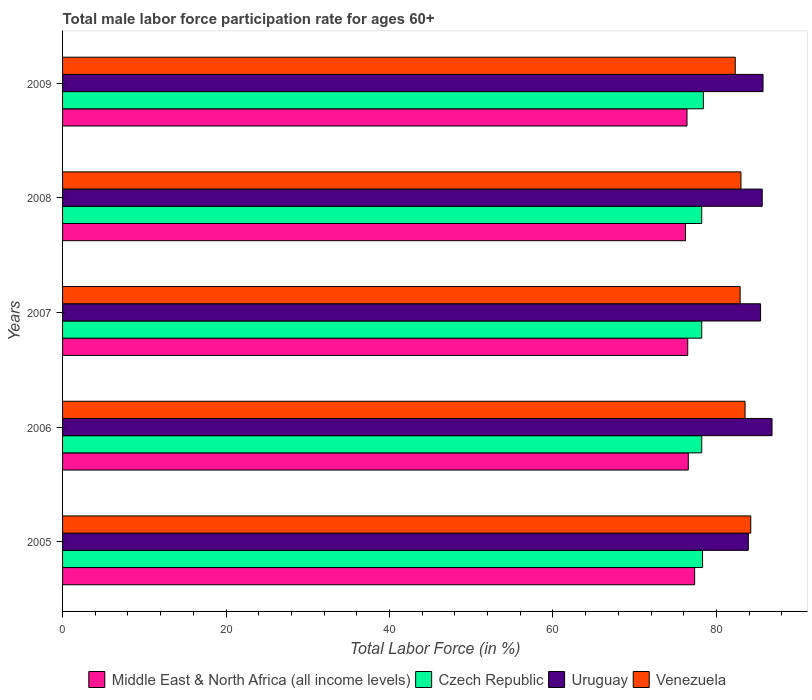How many different coloured bars are there?
Your answer should be compact. 4. How many bars are there on the 5th tick from the top?
Make the answer very short. 4. How many bars are there on the 2nd tick from the bottom?
Offer a very short reply. 4. What is the male labor force participation rate in Czech Republic in 2009?
Provide a short and direct response. 78.4. Across all years, what is the maximum male labor force participation rate in Venezuela?
Your answer should be very brief. 84.2. Across all years, what is the minimum male labor force participation rate in Middle East & North Africa (all income levels)?
Ensure brevity in your answer.  76.21. What is the total male labor force participation rate in Uruguay in the graph?
Give a very brief answer. 427.4. What is the difference between the male labor force participation rate in Uruguay in 2008 and that in 2009?
Offer a very short reply. -0.1. What is the difference between the male labor force participation rate in Venezuela in 2006 and the male labor force participation rate in Middle East & North Africa (all income levels) in 2009?
Make the answer very short. 7.1. What is the average male labor force participation rate in Middle East & North Africa (all income levels) per year?
Your answer should be compact. 76.6. In the year 2008, what is the difference between the male labor force participation rate in Uruguay and male labor force participation rate in Venezuela?
Your response must be concise. 2.6. In how many years, is the male labor force participation rate in Venezuela greater than 52 %?
Offer a very short reply. 5. What is the ratio of the male labor force participation rate in Uruguay in 2006 to that in 2008?
Your answer should be compact. 1.01. Is the male labor force participation rate in Uruguay in 2005 less than that in 2007?
Provide a succinct answer. Yes. Is the difference between the male labor force participation rate in Uruguay in 2006 and 2007 greater than the difference between the male labor force participation rate in Venezuela in 2006 and 2007?
Give a very brief answer. Yes. What is the difference between the highest and the second highest male labor force participation rate in Middle East & North Africa (all income levels)?
Offer a very short reply. 0.78. What is the difference between the highest and the lowest male labor force participation rate in Middle East & North Africa (all income levels)?
Keep it short and to the point. 1.12. In how many years, is the male labor force participation rate in Venezuela greater than the average male labor force participation rate in Venezuela taken over all years?
Keep it short and to the point. 2. What does the 4th bar from the top in 2006 represents?
Your answer should be compact. Middle East & North Africa (all income levels). What does the 2nd bar from the bottom in 2007 represents?
Give a very brief answer. Czech Republic. Is it the case that in every year, the sum of the male labor force participation rate in Uruguay and male labor force participation rate in Czech Republic is greater than the male labor force participation rate in Middle East & North Africa (all income levels)?
Provide a succinct answer. Yes. Are all the bars in the graph horizontal?
Your answer should be very brief. Yes. What is the difference between two consecutive major ticks on the X-axis?
Offer a terse response. 20. Does the graph contain grids?
Make the answer very short. No. How are the legend labels stacked?
Provide a succinct answer. Horizontal. What is the title of the graph?
Your answer should be very brief. Total male labor force participation rate for ages 60+. Does "Mongolia" appear as one of the legend labels in the graph?
Your answer should be very brief. No. What is the label or title of the X-axis?
Provide a succinct answer. Total Labor Force (in %). What is the Total Labor Force (in %) in Middle East & North Africa (all income levels) in 2005?
Keep it short and to the point. 77.33. What is the Total Labor Force (in %) in Czech Republic in 2005?
Provide a succinct answer. 78.3. What is the Total Labor Force (in %) in Uruguay in 2005?
Offer a terse response. 83.9. What is the Total Labor Force (in %) of Venezuela in 2005?
Give a very brief answer. 84.2. What is the Total Labor Force (in %) in Middle East & North Africa (all income levels) in 2006?
Your answer should be very brief. 76.56. What is the Total Labor Force (in %) of Czech Republic in 2006?
Offer a very short reply. 78.2. What is the Total Labor Force (in %) of Uruguay in 2006?
Make the answer very short. 86.8. What is the Total Labor Force (in %) of Venezuela in 2006?
Give a very brief answer. 83.5. What is the Total Labor Force (in %) of Middle East & North Africa (all income levels) in 2007?
Provide a succinct answer. 76.49. What is the Total Labor Force (in %) of Czech Republic in 2007?
Your response must be concise. 78.2. What is the Total Labor Force (in %) in Uruguay in 2007?
Offer a terse response. 85.4. What is the Total Labor Force (in %) in Venezuela in 2007?
Provide a succinct answer. 82.9. What is the Total Labor Force (in %) of Middle East & North Africa (all income levels) in 2008?
Offer a terse response. 76.21. What is the Total Labor Force (in %) of Czech Republic in 2008?
Offer a terse response. 78.2. What is the Total Labor Force (in %) of Uruguay in 2008?
Provide a short and direct response. 85.6. What is the Total Labor Force (in %) in Venezuela in 2008?
Give a very brief answer. 83. What is the Total Labor Force (in %) of Middle East & North Africa (all income levels) in 2009?
Ensure brevity in your answer.  76.4. What is the Total Labor Force (in %) in Czech Republic in 2009?
Ensure brevity in your answer.  78.4. What is the Total Labor Force (in %) of Uruguay in 2009?
Your answer should be compact. 85.7. What is the Total Labor Force (in %) in Venezuela in 2009?
Offer a very short reply. 82.3. Across all years, what is the maximum Total Labor Force (in %) in Middle East & North Africa (all income levels)?
Your response must be concise. 77.33. Across all years, what is the maximum Total Labor Force (in %) of Czech Republic?
Ensure brevity in your answer.  78.4. Across all years, what is the maximum Total Labor Force (in %) in Uruguay?
Keep it short and to the point. 86.8. Across all years, what is the maximum Total Labor Force (in %) of Venezuela?
Ensure brevity in your answer.  84.2. Across all years, what is the minimum Total Labor Force (in %) in Middle East & North Africa (all income levels)?
Provide a short and direct response. 76.21. Across all years, what is the minimum Total Labor Force (in %) of Czech Republic?
Give a very brief answer. 78.2. Across all years, what is the minimum Total Labor Force (in %) in Uruguay?
Give a very brief answer. 83.9. Across all years, what is the minimum Total Labor Force (in %) in Venezuela?
Offer a terse response. 82.3. What is the total Total Labor Force (in %) of Middle East & North Africa (all income levels) in the graph?
Your answer should be compact. 382.99. What is the total Total Labor Force (in %) of Czech Republic in the graph?
Keep it short and to the point. 391.3. What is the total Total Labor Force (in %) in Uruguay in the graph?
Make the answer very short. 427.4. What is the total Total Labor Force (in %) in Venezuela in the graph?
Keep it short and to the point. 415.9. What is the difference between the Total Labor Force (in %) in Middle East & North Africa (all income levels) in 2005 and that in 2006?
Your answer should be very brief. 0.78. What is the difference between the Total Labor Force (in %) of Czech Republic in 2005 and that in 2006?
Provide a short and direct response. 0.1. What is the difference between the Total Labor Force (in %) of Venezuela in 2005 and that in 2006?
Your answer should be compact. 0.7. What is the difference between the Total Labor Force (in %) in Middle East & North Africa (all income levels) in 2005 and that in 2007?
Your answer should be very brief. 0.85. What is the difference between the Total Labor Force (in %) in Czech Republic in 2005 and that in 2007?
Keep it short and to the point. 0.1. What is the difference between the Total Labor Force (in %) in Uruguay in 2005 and that in 2007?
Your response must be concise. -1.5. What is the difference between the Total Labor Force (in %) of Venezuela in 2005 and that in 2007?
Your answer should be very brief. 1.3. What is the difference between the Total Labor Force (in %) of Middle East & North Africa (all income levels) in 2005 and that in 2008?
Offer a terse response. 1.12. What is the difference between the Total Labor Force (in %) in Venezuela in 2005 and that in 2008?
Offer a very short reply. 1.2. What is the difference between the Total Labor Force (in %) of Middle East & North Africa (all income levels) in 2005 and that in 2009?
Offer a very short reply. 0.93. What is the difference between the Total Labor Force (in %) of Middle East & North Africa (all income levels) in 2006 and that in 2007?
Offer a terse response. 0.07. What is the difference between the Total Labor Force (in %) in Venezuela in 2006 and that in 2007?
Offer a very short reply. 0.6. What is the difference between the Total Labor Force (in %) of Middle East & North Africa (all income levels) in 2006 and that in 2008?
Offer a very short reply. 0.34. What is the difference between the Total Labor Force (in %) of Czech Republic in 2006 and that in 2008?
Your response must be concise. 0. What is the difference between the Total Labor Force (in %) of Uruguay in 2006 and that in 2008?
Offer a very short reply. 1.2. What is the difference between the Total Labor Force (in %) of Venezuela in 2006 and that in 2008?
Make the answer very short. 0.5. What is the difference between the Total Labor Force (in %) in Middle East & North Africa (all income levels) in 2006 and that in 2009?
Ensure brevity in your answer.  0.16. What is the difference between the Total Labor Force (in %) in Venezuela in 2006 and that in 2009?
Provide a succinct answer. 1.2. What is the difference between the Total Labor Force (in %) of Middle East & North Africa (all income levels) in 2007 and that in 2008?
Your answer should be compact. 0.27. What is the difference between the Total Labor Force (in %) of Czech Republic in 2007 and that in 2008?
Offer a terse response. 0. What is the difference between the Total Labor Force (in %) of Uruguay in 2007 and that in 2008?
Provide a short and direct response. -0.2. What is the difference between the Total Labor Force (in %) of Middle East & North Africa (all income levels) in 2007 and that in 2009?
Give a very brief answer. 0.09. What is the difference between the Total Labor Force (in %) of Uruguay in 2007 and that in 2009?
Offer a very short reply. -0.3. What is the difference between the Total Labor Force (in %) of Venezuela in 2007 and that in 2009?
Give a very brief answer. 0.6. What is the difference between the Total Labor Force (in %) of Middle East & North Africa (all income levels) in 2008 and that in 2009?
Provide a short and direct response. -0.18. What is the difference between the Total Labor Force (in %) of Czech Republic in 2008 and that in 2009?
Keep it short and to the point. -0.2. What is the difference between the Total Labor Force (in %) of Uruguay in 2008 and that in 2009?
Offer a terse response. -0.1. What is the difference between the Total Labor Force (in %) in Venezuela in 2008 and that in 2009?
Make the answer very short. 0.7. What is the difference between the Total Labor Force (in %) in Middle East & North Africa (all income levels) in 2005 and the Total Labor Force (in %) in Czech Republic in 2006?
Keep it short and to the point. -0.87. What is the difference between the Total Labor Force (in %) of Middle East & North Africa (all income levels) in 2005 and the Total Labor Force (in %) of Uruguay in 2006?
Ensure brevity in your answer.  -9.47. What is the difference between the Total Labor Force (in %) in Middle East & North Africa (all income levels) in 2005 and the Total Labor Force (in %) in Venezuela in 2006?
Provide a succinct answer. -6.17. What is the difference between the Total Labor Force (in %) in Czech Republic in 2005 and the Total Labor Force (in %) in Venezuela in 2006?
Keep it short and to the point. -5.2. What is the difference between the Total Labor Force (in %) in Middle East & North Africa (all income levels) in 2005 and the Total Labor Force (in %) in Czech Republic in 2007?
Your answer should be very brief. -0.87. What is the difference between the Total Labor Force (in %) of Middle East & North Africa (all income levels) in 2005 and the Total Labor Force (in %) of Uruguay in 2007?
Provide a succinct answer. -8.07. What is the difference between the Total Labor Force (in %) in Middle East & North Africa (all income levels) in 2005 and the Total Labor Force (in %) in Venezuela in 2007?
Your response must be concise. -5.57. What is the difference between the Total Labor Force (in %) in Czech Republic in 2005 and the Total Labor Force (in %) in Uruguay in 2007?
Make the answer very short. -7.1. What is the difference between the Total Labor Force (in %) in Czech Republic in 2005 and the Total Labor Force (in %) in Venezuela in 2007?
Keep it short and to the point. -4.6. What is the difference between the Total Labor Force (in %) of Uruguay in 2005 and the Total Labor Force (in %) of Venezuela in 2007?
Provide a succinct answer. 1. What is the difference between the Total Labor Force (in %) in Middle East & North Africa (all income levels) in 2005 and the Total Labor Force (in %) in Czech Republic in 2008?
Offer a terse response. -0.87. What is the difference between the Total Labor Force (in %) of Middle East & North Africa (all income levels) in 2005 and the Total Labor Force (in %) of Uruguay in 2008?
Offer a terse response. -8.27. What is the difference between the Total Labor Force (in %) in Middle East & North Africa (all income levels) in 2005 and the Total Labor Force (in %) in Venezuela in 2008?
Your answer should be compact. -5.67. What is the difference between the Total Labor Force (in %) in Czech Republic in 2005 and the Total Labor Force (in %) in Uruguay in 2008?
Offer a terse response. -7.3. What is the difference between the Total Labor Force (in %) of Czech Republic in 2005 and the Total Labor Force (in %) of Venezuela in 2008?
Ensure brevity in your answer.  -4.7. What is the difference between the Total Labor Force (in %) in Middle East & North Africa (all income levels) in 2005 and the Total Labor Force (in %) in Czech Republic in 2009?
Offer a terse response. -1.07. What is the difference between the Total Labor Force (in %) of Middle East & North Africa (all income levels) in 2005 and the Total Labor Force (in %) of Uruguay in 2009?
Your answer should be very brief. -8.37. What is the difference between the Total Labor Force (in %) of Middle East & North Africa (all income levels) in 2005 and the Total Labor Force (in %) of Venezuela in 2009?
Provide a short and direct response. -4.97. What is the difference between the Total Labor Force (in %) in Czech Republic in 2005 and the Total Labor Force (in %) in Venezuela in 2009?
Your answer should be compact. -4. What is the difference between the Total Labor Force (in %) of Uruguay in 2005 and the Total Labor Force (in %) of Venezuela in 2009?
Offer a very short reply. 1.6. What is the difference between the Total Labor Force (in %) in Middle East & North Africa (all income levels) in 2006 and the Total Labor Force (in %) in Czech Republic in 2007?
Keep it short and to the point. -1.64. What is the difference between the Total Labor Force (in %) in Middle East & North Africa (all income levels) in 2006 and the Total Labor Force (in %) in Uruguay in 2007?
Keep it short and to the point. -8.84. What is the difference between the Total Labor Force (in %) in Middle East & North Africa (all income levels) in 2006 and the Total Labor Force (in %) in Venezuela in 2007?
Ensure brevity in your answer.  -6.34. What is the difference between the Total Labor Force (in %) of Czech Republic in 2006 and the Total Labor Force (in %) of Uruguay in 2007?
Your answer should be very brief. -7.2. What is the difference between the Total Labor Force (in %) of Uruguay in 2006 and the Total Labor Force (in %) of Venezuela in 2007?
Give a very brief answer. 3.9. What is the difference between the Total Labor Force (in %) in Middle East & North Africa (all income levels) in 2006 and the Total Labor Force (in %) in Czech Republic in 2008?
Provide a succinct answer. -1.64. What is the difference between the Total Labor Force (in %) of Middle East & North Africa (all income levels) in 2006 and the Total Labor Force (in %) of Uruguay in 2008?
Provide a short and direct response. -9.04. What is the difference between the Total Labor Force (in %) of Middle East & North Africa (all income levels) in 2006 and the Total Labor Force (in %) of Venezuela in 2008?
Your answer should be very brief. -6.44. What is the difference between the Total Labor Force (in %) in Czech Republic in 2006 and the Total Labor Force (in %) in Uruguay in 2008?
Your response must be concise. -7.4. What is the difference between the Total Labor Force (in %) of Czech Republic in 2006 and the Total Labor Force (in %) of Venezuela in 2008?
Offer a very short reply. -4.8. What is the difference between the Total Labor Force (in %) of Middle East & North Africa (all income levels) in 2006 and the Total Labor Force (in %) of Czech Republic in 2009?
Your response must be concise. -1.84. What is the difference between the Total Labor Force (in %) of Middle East & North Africa (all income levels) in 2006 and the Total Labor Force (in %) of Uruguay in 2009?
Offer a very short reply. -9.14. What is the difference between the Total Labor Force (in %) of Middle East & North Africa (all income levels) in 2006 and the Total Labor Force (in %) of Venezuela in 2009?
Your response must be concise. -5.74. What is the difference between the Total Labor Force (in %) in Uruguay in 2006 and the Total Labor Force (in %) in Venezuela in 2009?
Your answer should be compact. 4.5. What is the difference between the Total Labor Force (in %) in Middle East & North Africa (all income levels) in 2007 and the Total Labor Force (in %) in Czech Republic in 2008?
Ensure brevity in your answer.  -1.71. What is the difference between the Total Labor Force (in %) in Middle East & North Africa (all income levels) in 2007 and the Total Labor Force (in %) in Uruguay in 2008?
Your answer should be compact. -9.11. What is the difference between the Total Labor Force (in %) in Middle East & North Africa (all income levels) in 2007 and the Total Labor Force (in %) in Venezuela in 2008?
Provide a succinct answer. -6.51. What is the difference between the Total Labor Force (in %) of Czech Republic in 2007 and the Total Labor Force (in %) of Venezuela in 2008?
Provide a short and direct response. -4.8. What is the difference between the Total Labor Force (in %) in Middle East & North Africa (all income levels) in 2007 and the Total Labor Force (in %) in Czech Republic in 2009?
Give a very brief answer. -1.91. What is the difference between the Total Labor Force (in %) in Middle East & North Africa (all income levels) in 2007 and the Total Labor Force (in %) in Uruguay in 2009?
Your answer should be very brief. -9.21. What is the difference between the Total Labor Force (in %) of Middle East & North Africa (all income levels) in 2007 and the Total Labor Force (in %) of Venezuela in 2009?
Ensure brevity in your answer.  -5.81. What is the difference between the Total Labor Force (in %) of Middle East & North Africa (all income levels) in 2008 and the Total Labor Force (in %) of Czech Republic in 2009?
Keep it short and to the point. -2.19. What is the difference between the Total Labor Force (in %) of Middle East & North Africa (all income levels) in 2008 and the Total Labor Force (in %) of Uruguay in 2009?
Keep it short and to the point. -9.49. What is the difference between the Total Labor Force (in %) of Middle East & North Africa (all income levels) in 2008 and the Total Labor Force (in %) of Venezuela in 2009?
Provide a short and direct response. -6.09. What is the difference between the Total Labor Force (in %) in Czech Republic in 2008 and the Total Labor Force (in %) in Uruguay in 2009?
Keep it short and to the point. -7.5. What is the average Total Labor Force (in %) in Middle East & North Africa (all income levels) per year?
Your answer should be compact. 76.6. What is the average Total Labor Force (in %) in Czech Republic per year?
Make the answer very short. 78.26. What is the average Total Labor Force (in %) of Uruguay per year?
Offer a very short reply. 85.48. What is the average Total Labor Force (in %) in Venezuela per year?
Make the answer very short. 83.18. In the year 2005, what is the difference between the Total Labor Force (in %) in Middle East & North Africa (all income levels) and Total Labor Force (in %) in Czech Republic?
Your answer should be very brief. -0.97. In the year 2005, what is the difference between the Total Labor Force (in %) in Middle East & North Africa (all income levels) and Total Labor Force (in %) in Uruguay?
Offer a terse response. -6.57. In the year 2005, what is the difference between the Total Labor Force (in %) in Middle East & North Africa (all income levels) and Total Labor Force (in %) in Venezuela?
Give a very brief answer. -6.87. In the year 2005, what is the difference between the Total Labor Force (in %) in Czech Republic and Total Labor Force (in %) in Venezuela?
Keep it short and to the point. -5.9. In the year 2005, what is the difference between the Total Labor Force (in %) of Uruguay and Total Labor Force (in %) of Venezuela?
Make the answer very short. -0.3. In the year 2006, what is the difference between the Total Labor Force (in %) in Middle East & North Africa (all income levels) and Total Labor Force (in %) in Czech Republic?
Ensure brevity in your answer.  -1.64. In the year 2006, what is the difference between the Total Labor Force (in %) in Middle East & North Africa (all income levels) and Total Labor Force (in %) in Uruguay?
Make the answer very short. -10.24. In the year 2006, what is the difference between the Total Labor Force (in %) in Middle East & North Africa (all income levels) and Total Labor Force (in %) in Venezuela?
Provide a short and direct response. -6.94. In the year 2006, what is the difference between the Total Labor Force (in %) in Czech Republic and Total Labor Force (in %) in Venezuela?
Provide a short and direct response. -5.3. In the year 2006, what is the difference between the Total Labor Force (in %) of Uruguay and Total Labor Force (in %) of Venezuela?
Provide a short and direct response. 3.3. In the year 2007, what is the difference between the Total Labor Force (in %) of Middle East & North Africa (all income levels) and Total Labor Force (in %) of Czech Republic?
Make the answer very short. -1.71. In the year 2007, what is the difference between the Total Labor Force (in %) in Middle East & North Africa (all income levels) and Total Labor Force (in %) in Uruguay?
Offer a terse response. -8.91. In the year 2007, what is the difference between the Total Labor Force (in %) of Middle East & North Africa (all income levels) and Total Labor Force (in %) of Venezuela?
Give a very brief answer. -6.41. In the year 2008, what is the difference between the Total Labor Force (in %) in Middle East & North Africa (all income levels) and Total Labor Force (in %) in Czech Republic?
Keep it short and to the point. -1.99. In the year 2008, what is the difference between the Total Labor Force (in %) of Middle East & North Africa (all income levels) and Total Labor Force (in %) of Uruguay?
Provide a short and direct response. -9.39. In the year 2008, what is the difference between the Total Labor Force (in %) in Middle East & North Africa (all income levels) and Total Labor Force (in %) in Venezuela?
Your answer should be compact. -6.79. In the year 2008, what is the difference between the Total Labor Force (in %) of Czech Republic and Total Labor Force (in %) of Venezuela?
Ensure brevity in your answer.  -4.8. In the year 2008, what is the difference between the Total Labor Force (in %) in Uruguay and Total Labor Force (in %) in Venezuela?
Your answer should be very brief. 2.6. In the year 2009, what is the difference between the Total Labor Force (in %) in Middle East & North Africa (all income levels) and Total Labor Force (in %) in Czech Republic?
Your answer should be compact. -2. In the year 2009, what is the difference between the Total Labor Force (in %) in Middle East & North Africa (all income levels) and Total Labor Force (in %) in Uruguay?
Make the answer very short. -9.3. In the year 2009, what is the difference between the Total Labor Force (in %) of Middle East & North Africa (all income levels) and Total Labor Force (in %) of Venezuela?
Offer a terse response. -5.9. What is the ratio of the Total Labor Force (in %) in Middle East & North Africa (all income levels) in 2005 to that in 2006?
Offer a terse response. 1.01. What is the ratio of the Total Labor Force (in %) of Uruguay in 2005 to that in 2006?
Provide a short and direct response. 0.97. What is the ratio of the Total Labor Force (in %) in Venezuela in 2005 to that in 2006?
Provide a short and direct response. 1.01. What is the ratio of the Total Labor Force (in %) in Middle East & North Africa (all income levels) in 2005 to that in 2007?
Your answer should be compact. 1.01. What is the ratio of the Total Labor Force (in %) of Czech Republic in 2005 to that in 2007?
Offer a very short reply. 1. What is the ratio of the Total Labor Force (in %) in Uruguay in 2005 to that in 2007?
Keep it short and to the point. 0.98. What is the ratio of the Total Labor Force (in %) in Venezuela in 2005 to that in 2007?
Give a very brief answer. 1.02. What is the ratio of the Total Labor Force (in %) of Middle East & North Africa (all income levels) in 2005 to that in 2008?
Offer a terse response. 1.01. What is the ratio of the Total Labor Force (in %) in Uruguay in 2005 to that in 2008?
Provide a short and direct response. 0.98. What is the ratio of the Total Labor Force (in %) in Venezuela in 2005 to that in 2008?
Keep it short and to the point. 1.01. What is the ratio of the Total Labor Force (in %) of Middle East & North Africa (all income levels) in 2005 to that in 2009?
Your response must be concise. 1.01. What is the ratio of the Total Labor Force (in %) of Czech Republic in 2005 to that in 2009?
Offer a terse response. 1. What is the ratio of the Total Labor Force (in %) of Venezuela in 2005 to that in 2009?
Give a very brief answer. 1.02. What is the ratio of the Total Labor Force (in %) of Uruguay in 2006 to that in 2007?
Your answer should be very brief. 1.02. What is the ratio of the Total Labor Force (in %) in Middle East & North Africa (all income levels) in 2006 to that in 2008?
Provide a succinct answer. 1. What is the ratio of the Total Labor Force (in %) in Uruguay in 2006 to that in 2008?
Ensure brevity in your answer.  1.01. What is the ratio of the Total Labor Force (in %) in Venezuela in 2006 to that in 2008?
Your response must be concise. 1.01. What is the ratio of the Total Labor Force (in %) in Uruguay in 2006 to that in 2009?
Your answer should be compact. 1.01. What is the ratio of the Total Labor Force (in %) in Venezuela in 2006 to that in 2009?
Your response must be concise. 1.01. What is the ratio of the Total Labor Force (in %) of Uruguay in 2007 to that in 2008?
Ensure brevity in your answer.  1. What is the ratio of the Total Labor Force (in %) of Venezuela in 2007 to that in 2009?
Provide a succinct answer. 1.01. What is the ratio of the Total Labor Force (in %) in Middle East & North Africa (all income levels) in 2008 to that in 2009?
Your answer should be very brief. 1. What is the ratio of the Total Labor Force (in %) in Uruguay in 2008 to that in 2009?
Ensure brevity in your answer.  1. What is the ratio of the Total Labor Force (in %) in Venezuela in 2008 to that in 2009?
Ensure brevity in your answer.  1.01. What is the difference between the highest and the second highest Total Labor Force (in %) in Middle East & North Africa (all income levels)?
Your response must be concise. 0.78. What is the difference between the highest and the second highest Total Labor Force (in %) of Czech Republic?
Ensure brevity in your answer.  0.1. What is the difference between the highest and the second highest Total Labor Force (in %) in Uruguay?
Ensure brevity in your answer.  1.1. What is the difference between the highest and the lowest Total Labor Force (in %) of Middle East & North Africa (all income levels)?
Your answer should be compact. 1.12. What is the difference between the highest and the lowest Total Labor Force (in %) of Czech Republic?
Keep it short and to the point. 0.2. 